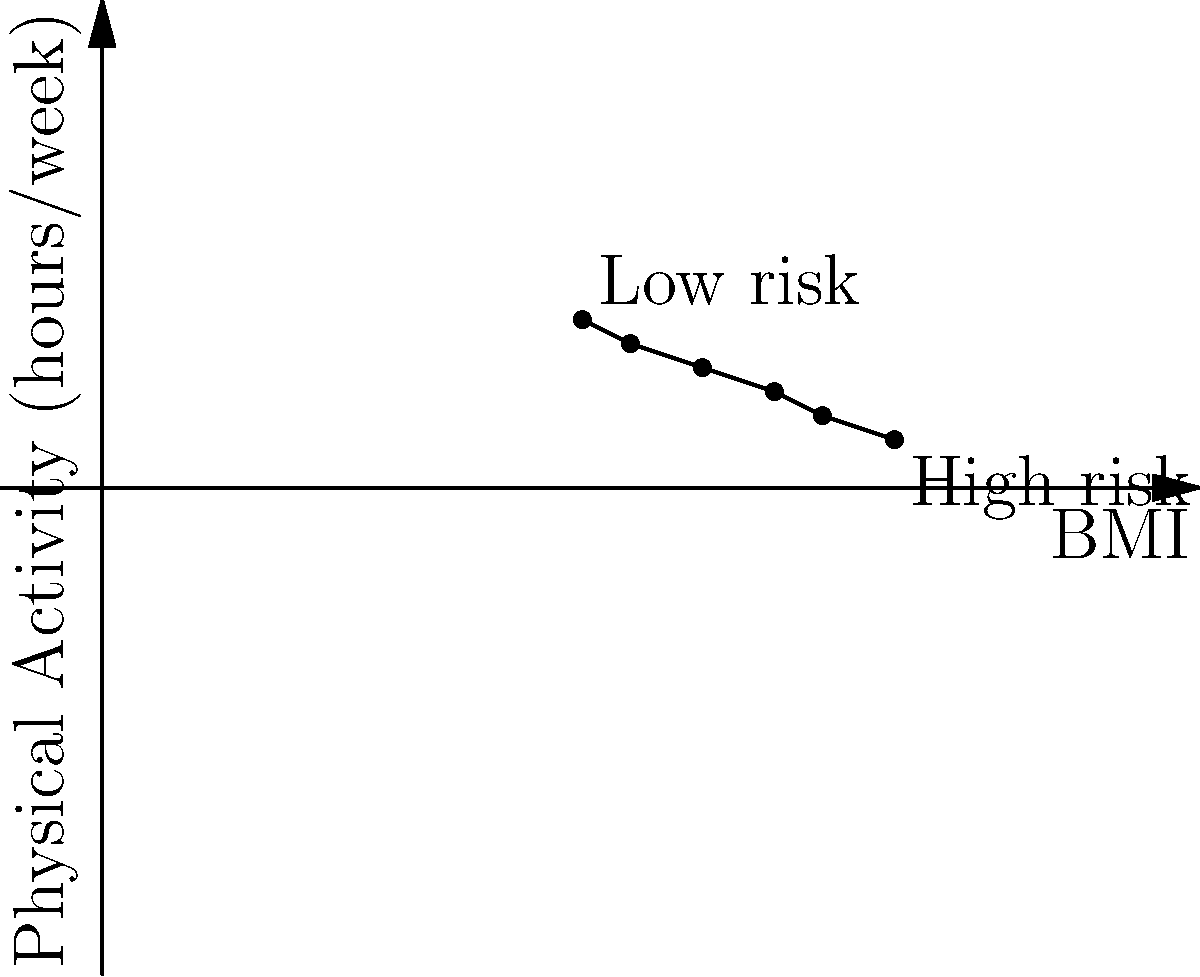The graph shows the relationship between BMI and physical activity levels, with each point representing a group of individuals. As an advocate for breast cancer awareness, how would you interpret this graph in terms of breast cancer risk, and what specific lifestyle recommendation would you emphasize based on this data? To interpret this graph and provide a lifestyle recommendation:

1. Observe the trend: The graph shows a negative correlation between BMI and physical activity.

2. Understand the axes:
   - X-axis: BMI (Body Mass Index)
   - Y-axis: Physical Activity (hours/week)

3. Interpret the trend:
   - As BMI increases, physical activity decreases.
   - Lower BMI and higher physical activity are associated with lower breast cancer risk.
   - Higher BMI and lower physical activity are associated with higher breast cancer risk.

4. Identify risk zones:
   - Low risk: Lower left corner (low BMI, high physical activity)
   - High risk: Upper right corner (high BMI, low physical activity)

5. Consider breast cancer risk factors:
   - High BMI (obesity) is a known risk factor for breast cancer.
   - Regular physical activity can help reduce breast cancer risk.

6. Formulate a recommendation:
   - Emphasize the importance of maintaining a healthy BMI through diet and regular exercise.
   - Specifically, recommend increasing physical activity levels, as it can help both in reducing BMI and directly lowering breast cancer risk.

Based on this analysis, the most effective lifestyle recommendation would be to increase physical activity levels, aiming for at least 5-7 hours per week of moderate exercise.
Answer: Increase physical activity to 5-7 hours/week 